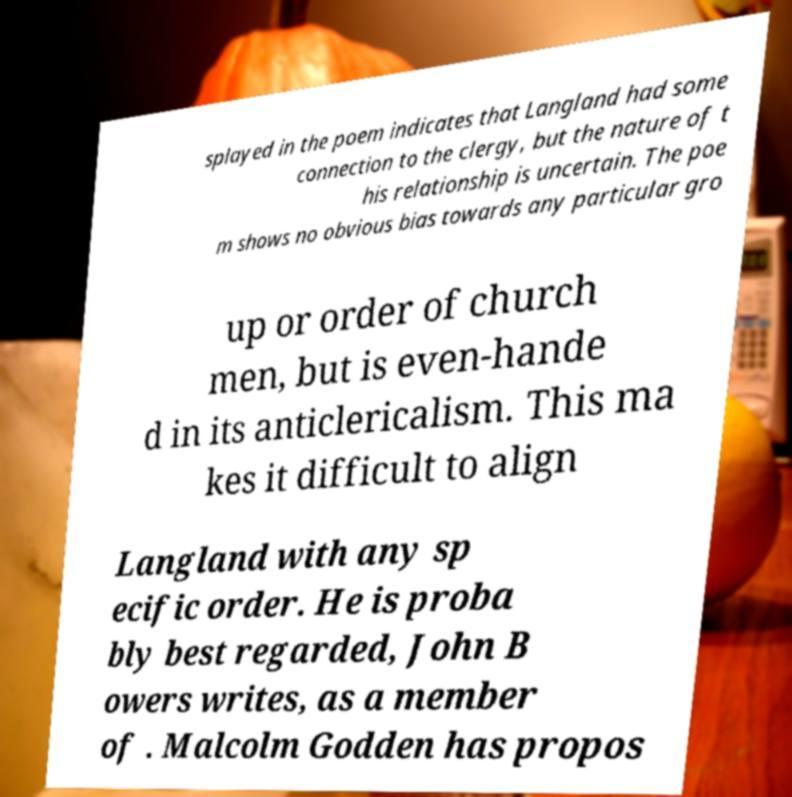What messages or text are displayed in this image? I need them in a readable, typed format. splayed in the poem indicates that Langland had some connection to the clergy, but the nature of t his relationship is uncertain. The poe m shows no obvious bias towards any particular gro up or order of church men, but is even-hande d in its anticlericalism. This ma kes it difficult to align Langland with any sp ecific order. He is proba bly best regarded, John B owers writes, as a member of . Malcolm Godden has propos 